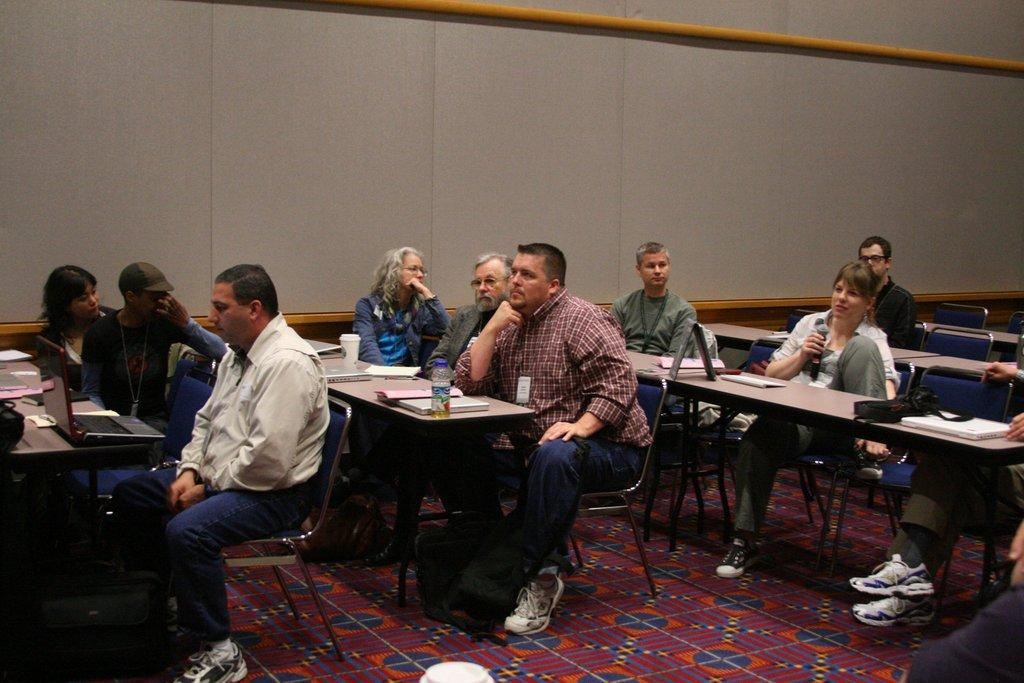How many people are in the image? There is a group of people in the image. What are the people in the image doing? The people are sitting. Can you describe the woman in the image? The woman is holding a microphone. What is on the floor in the image? There is a carpet on the floor. What type of coat is the bat wearing in the image? There is no bat or coat present in the image. 